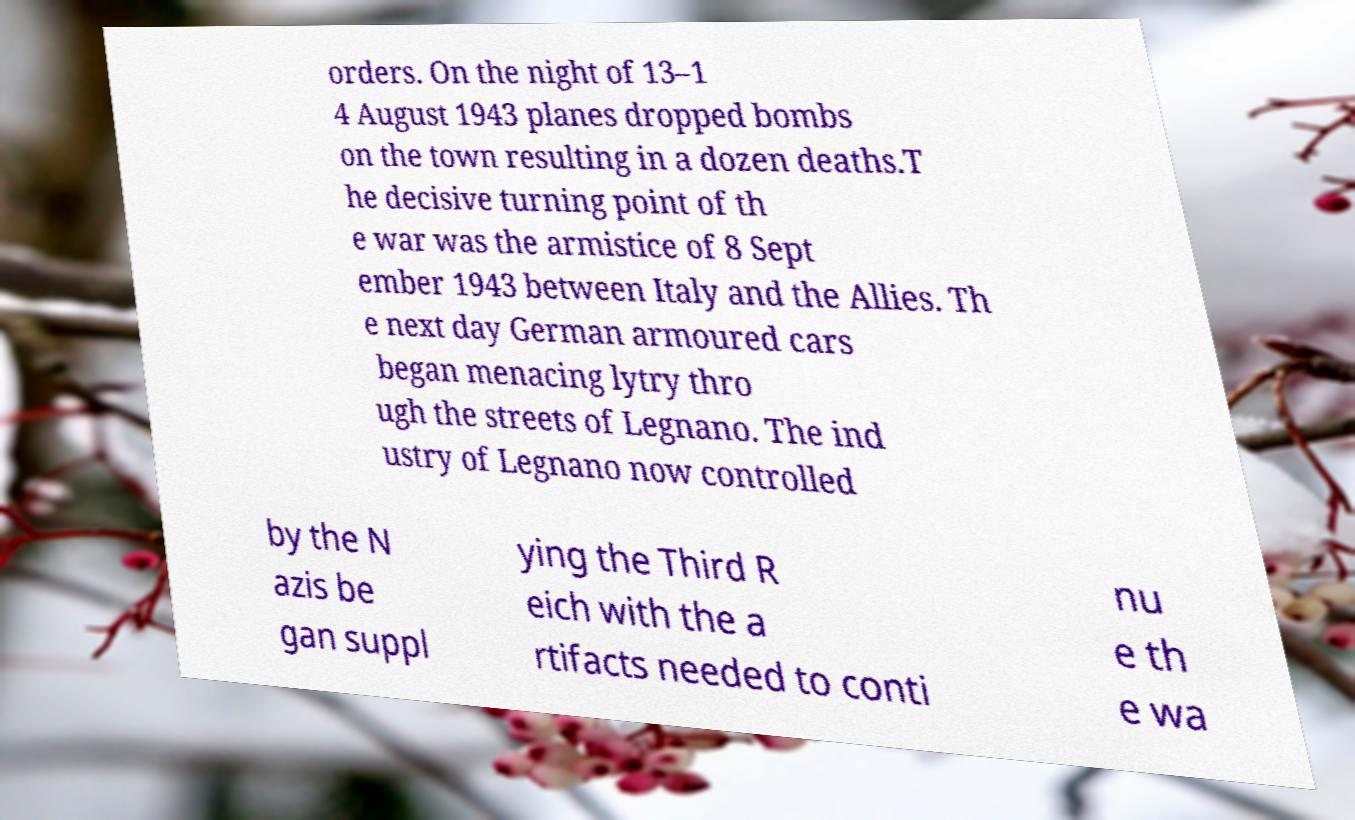Please read and relay the text visible in this image. What does it say? orders. On the night of 13–1 4 August 1943 planes dropped bombs on the town resulting in a dozen deaths.T he decisive turning point of th e war was the armistice of 8 Sept ember 1943 between Italy and the Allies. Th e next day German armoured cars began menacing lytry thro ugh the streets of Legnano. The ind ustry of Legnano now controlled by the N azis be gan suppl ying the Third R eich with the a rtifacts needed to conti nu e th e wa 